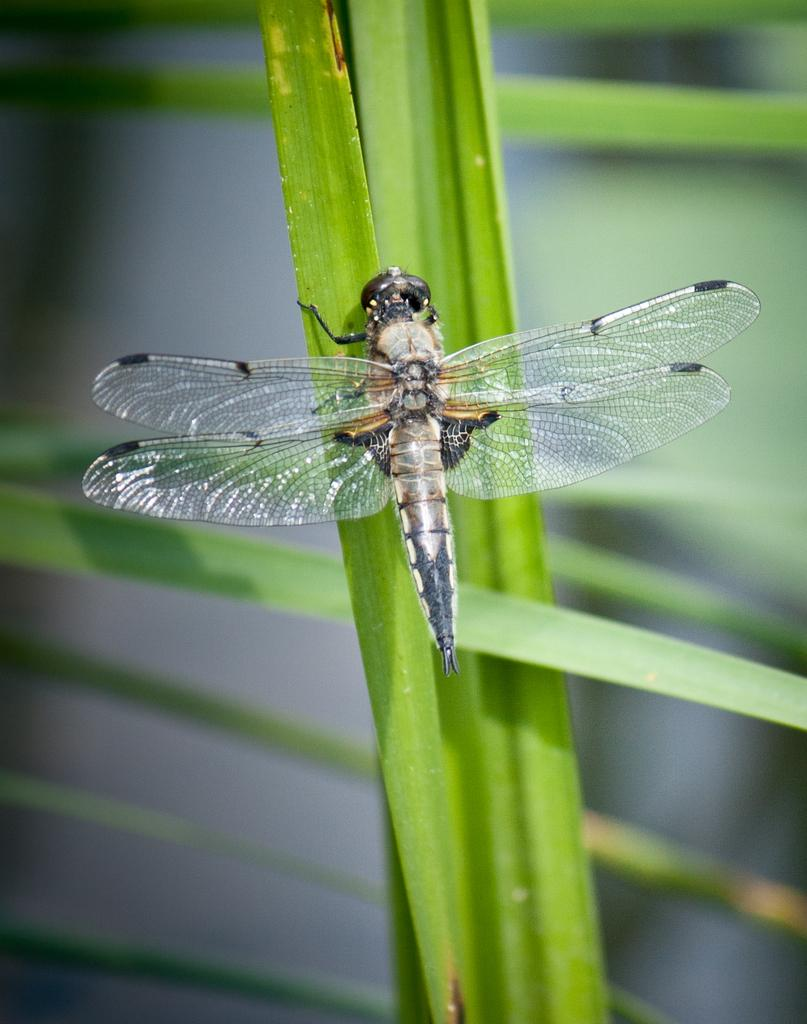Where was the image taken? The image was taken outdoors. Can you describe the background of the image? The background of the image is slightly blurred. What type of vegetation can be seen in the image? There are leaves in the image. What animal is present in the image? There is a dragonfly in the image. On which part of the vegetation is the dragonfly resting? The dragonfly is on a green leaf. How many beans are scattered around the dragonfly in the image? There are no beans present in the image. What type of giants can be seen walking in the background of the image? There are no giants present in the image. 